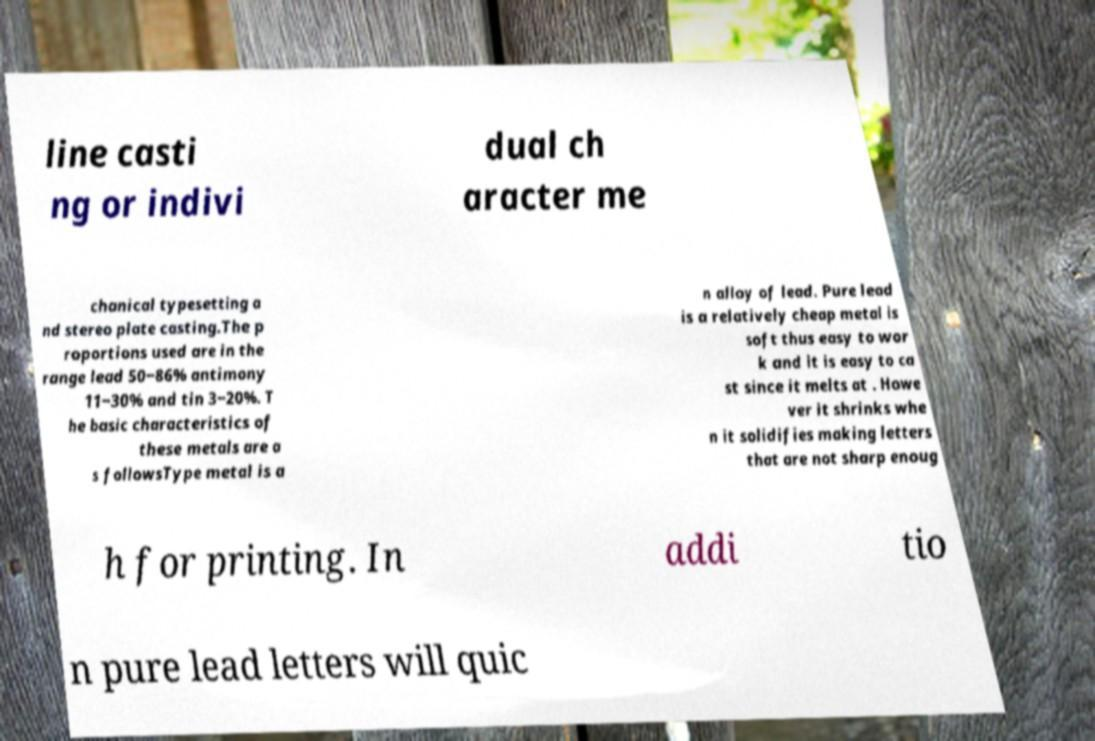Please identify and transcribe the text found in this image. line casti ng or indivi dual ch aracter me chanical typesetting a nd stereo plate casting.The p roportions used are in the range lead 50‒86% antimony 11‒30% and tin 3‒20%. T he basic characteristics of these metals are a s followsType metal is a n alloy of lead. Pure lead is a relatively cheap metal is soft thus easy to wor k and it is easy to ca st since it melts at . Howe ver it shrinks whe n it solidifies making letters that are not sharp enoug h for printing. In addi tio n pure lead letters will quic 